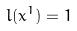Convert formula to latex. <formula><loc_0><loc_0><loc_500><loc_500>l ( x ^ { 1 } ) = 1</formula> 